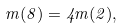<formula> <loc_0><loc_0><loc_500><loc_500>m ( 8 ) = 4 m ( 2 ) ,</formula> 